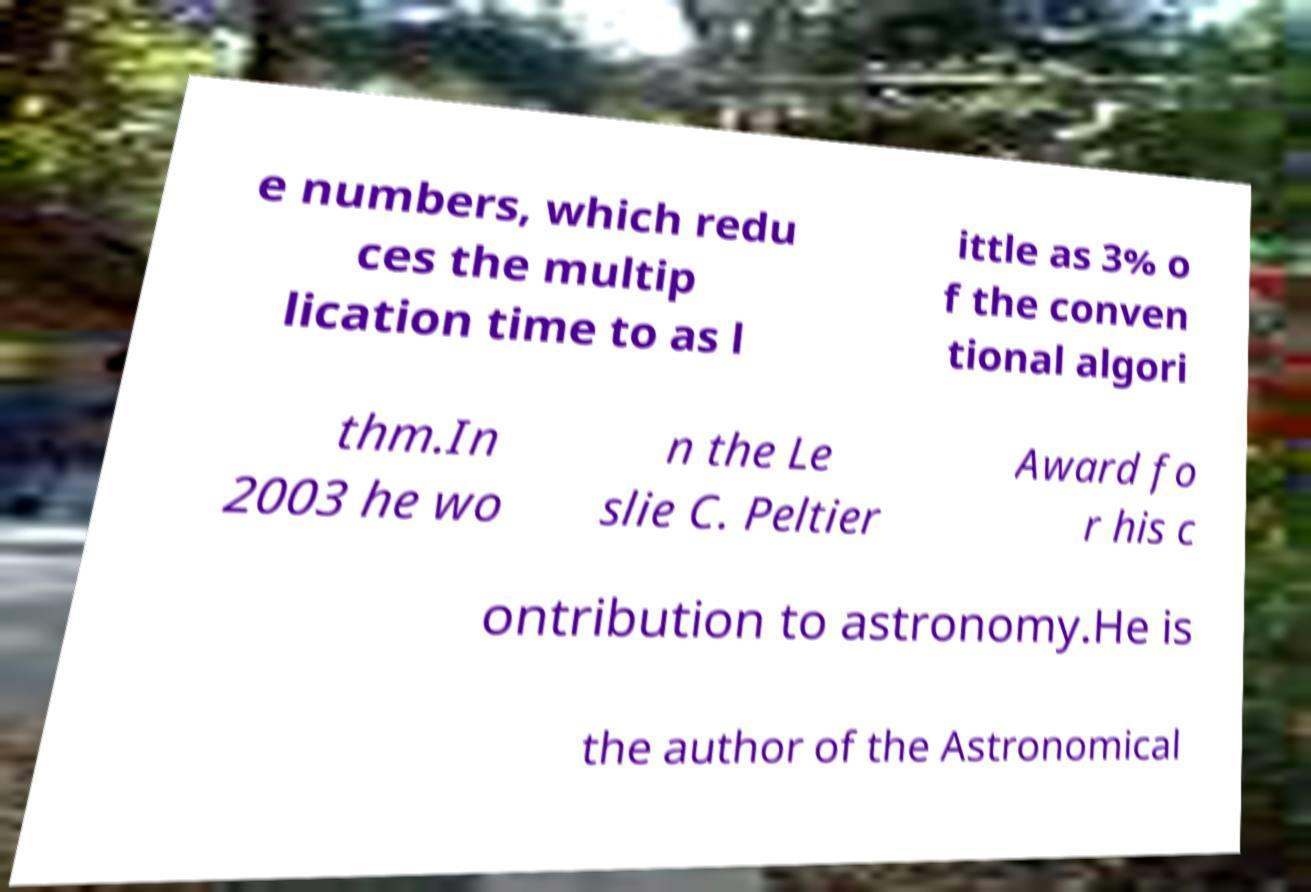Can you read and provide the text displayed in the image?This photo seems to have some interesting text. Can you extract and type it out for me? e numbers, which redu ces the multip lication time to as l ittle as 3% o f the conven tional algori thm.In 2003 he wo n the Le slie C. Peltier Award fo r his c ontribution to astronomy.He is the author of the Astronomical 